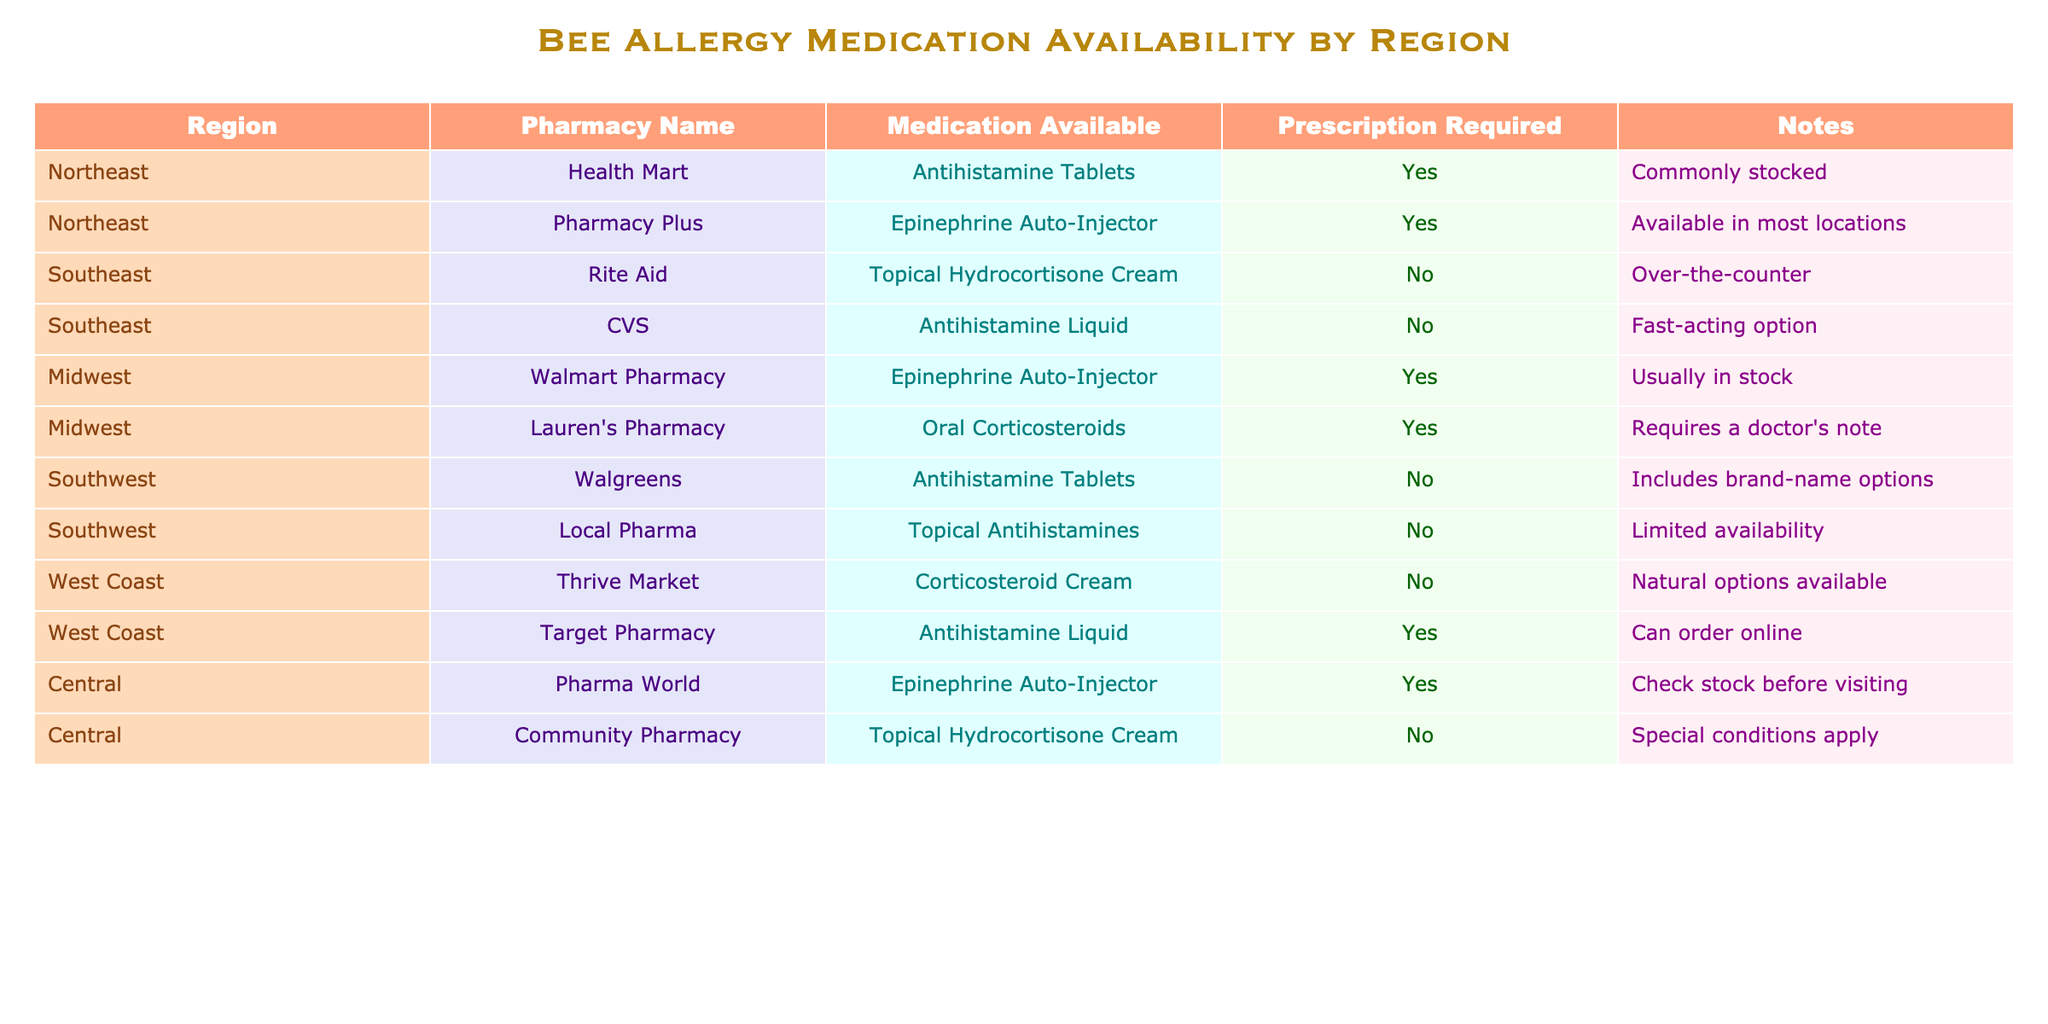What pharmacy in the Northeast offers an Epinephrine Auto-Injector? The table shows that Pharmacy Plus is the pharmacy in the Northeast that offers an Epinephrine Auto-Injector.
Answer: Pharmacy Plus Is a prescription required for antihistamine tablets in the Southwest? The table indicates that Walgreens offers antihistamine tablets without a prescription in the Southwest.
Answer: No How many types of medications are available in the Midwest region? The table shows two types of medications available in the Midwest: Epinephrine Auto-Injector and Oral Corticosteroids, so the total is 2.
Answer: 2 Which region has the most pharmacies listed? By counting the number of pharmacies in each region, the Northeast has 2 pharmacies listed, the Southeast has 2, the Midwest has 2, the Southwest has 2, the West Coast has 2, and Central has 2, resulting in a tie with all regions having 2 pharmacies.
Answer: None Is topical hydrocortisone cream available without a prescription in the Central region? The table shows that Community Pharmacy in the Central region offers topical hydrocortisone cream without a prescription.
Answer: No What is the combined total of medications requiring a prescription across all regions? From the table, the pharmacies that require prescriptions are Health Mart, Pharmacy Plus, Walmart Pharmacy, Lauren's Pharmacy, and Pharma World, which total to 5 medications requiring a prescription.
Answer: 5 Does Thrive Market offer any over-the-counter medications? The table indicates that Thrive Market does not offer over-the-counter medications; instead, it provides Corticosteroid Cream, which is not listed as over-the-counter.
Answer: No In which region can you find antihistamine liquid without a prescription? The table specifies that CVS in the Southeast offers antihistamine liquid without a prescription.
Answer: Southeast What type of medication is available at Walgreens in the Southwest? Walgreens in the Southwest offers antihistamine tablets, according to the table.
Answer: Antihistamine Tablets How many regions have Epinephrine Auto-Injectors available? By reviewing the table, Epinephrine Auto-Injectors are available in the Northeast, Midwest, and Central regions, totaling 3 regions.
Answer: 3 